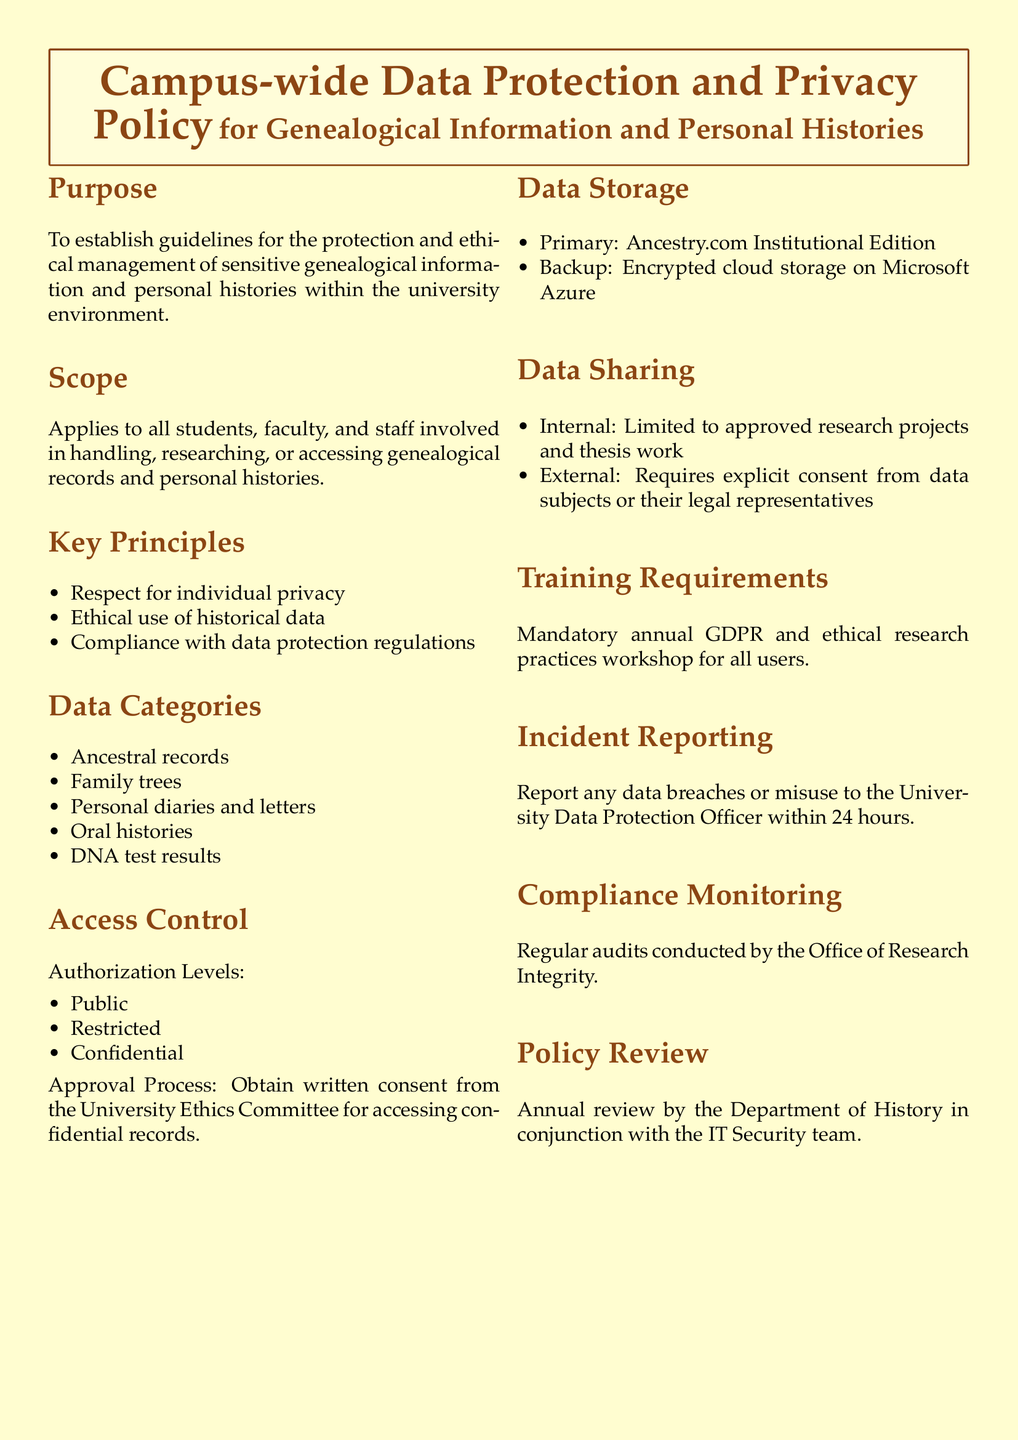What is the purpose of the policy? The purpose is to establish guidelines for the protection and ethical management of sensitive genealogical information and personal histories within the university environment.
Answer: To establish guidelines for the protection and ethical management of sensitive genealogical information and personal histories within the university environment Who does the scope apply to? The scope applies to all students, faculty, and staff involved in handling, researching, or accessing genealogical records and personal histories.
Answer: All students, faculty, and staff What are the data categories mentioned in the policy? The data categories listed include ancestral records, family trees, personal diaries and letters, oral histories, and DNA test results.
Answer: Ancestral records, family trees, personal diaries and letters, oral histories, DNA test results What is the main data storage solution used? The primary data storage solution mentioned in the policy is Ancestry.com Institutional Edition.
Answer: Ancestry.com Institutional Edition What is required for accessing confidential records? The approval process requires obtaining written consent from the University Ethics Committee.
Answer: Written consent from the University Ethics Committee How often are audits conducted for compliance monitoring? Audits are conducted regularly, specifically mentioned in the document as annual audits.
Answer: Regular audits What training is required for users? Mandatory annual GDPR and ethical research practices workshop for all users is required.
Answer: Mandatory annual GDPR and ethical research practices workshop What should be done within 24 hours of a data breach? Any data breaches or misuse must be reported to the University Data Protection Officer within 24 hours.
Answer: Report to the University Data Protection Officer within 24 hours How often is the policy reviewed? The policy is reviewed annually by the Department of History in conjunction with the IT Security team.
Answer: Annually 